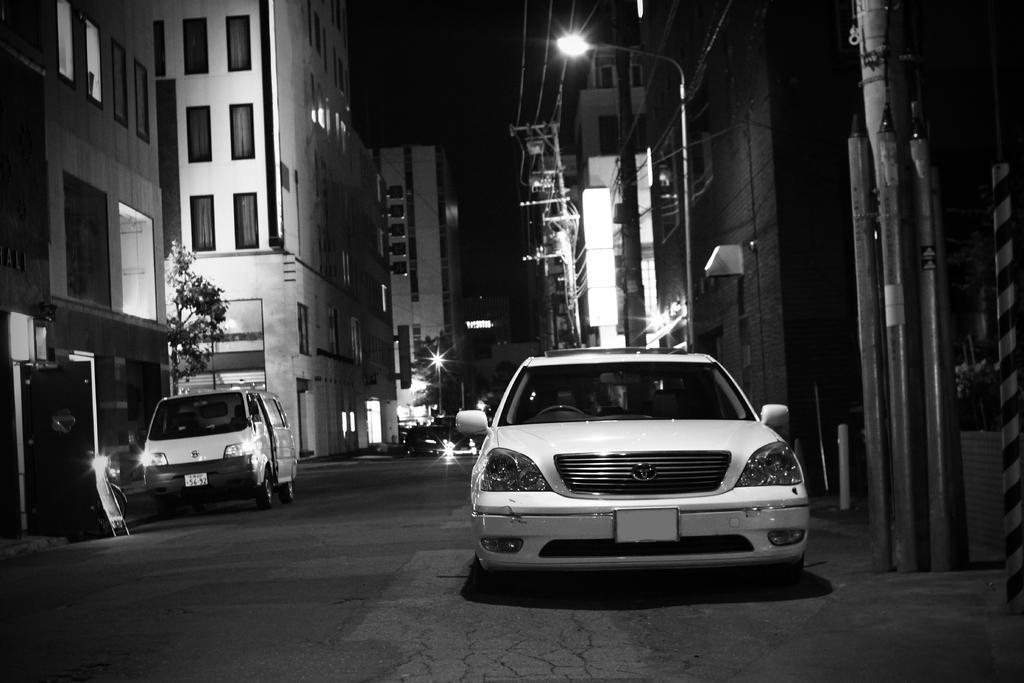Could you give a brief overview of what you see in this image? This is a black and white image. In this image we can see some vehicles on the road, some buildings with windows, an utility pole with wires, lights, street poles, some trees and the sky. 